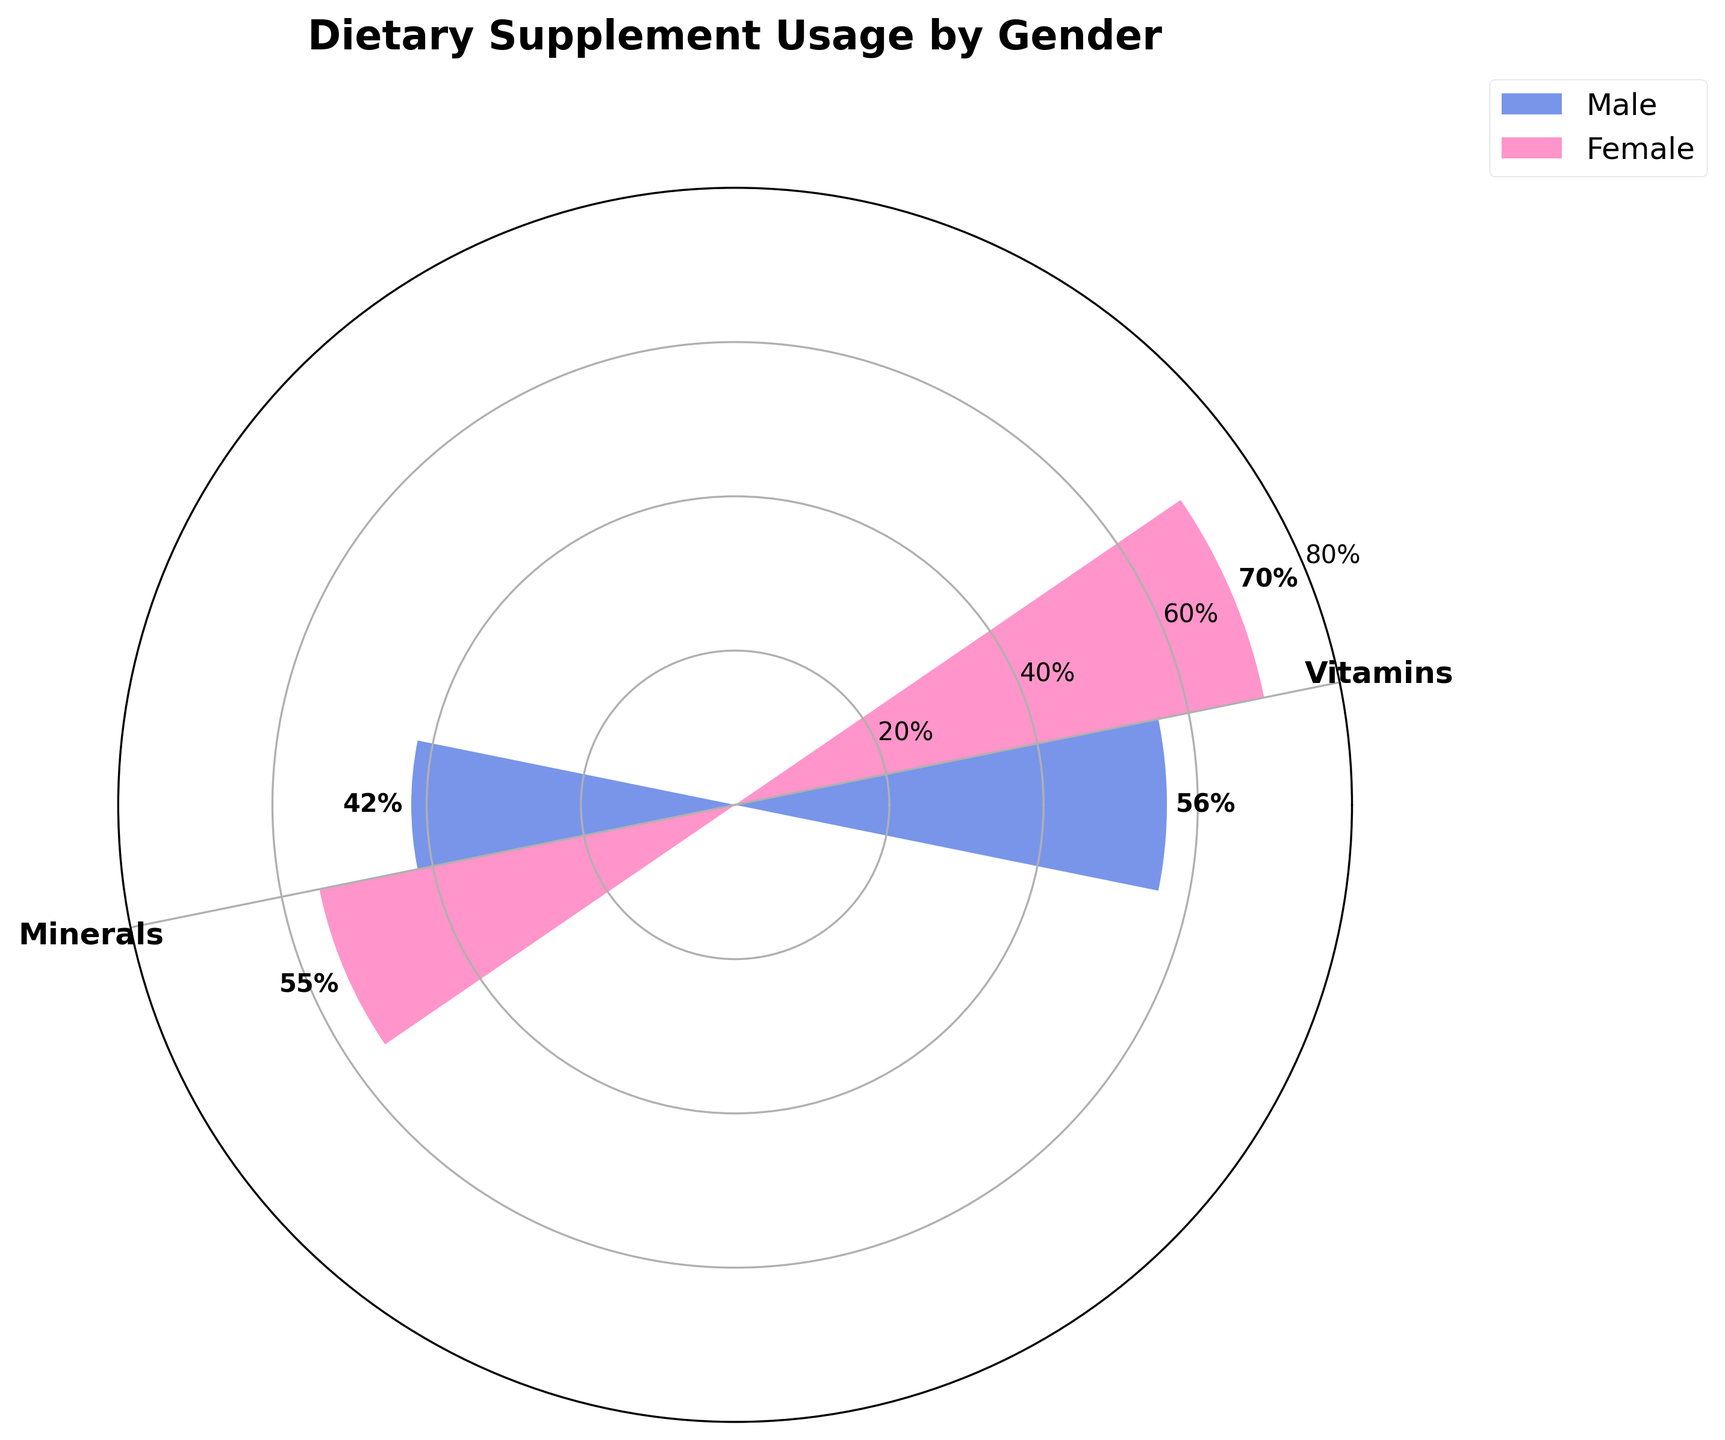What is the title of the chart? The title of the chart is located at the top and reads "Dietary Supplement Usage by Gender".
Answer: Dietary Supplement Usage by Gender How many groups are shown in the chart and what are their names? The chart shows two groups, labeled as "Vitamins" and "Minerals" in the legend.
Answer: 2, Vitamins and Minerals Which gender has the highest usage rate of vitamins? By looking at the bars for Vitamins, the Female bar is taller compared to the Male bar, indicating that females have the highest usage rate of vitamins.
Answer: Female What is the difference in usage rate of minerals between males and females? The usage rate of minerals for males is 42% and for females is 55%. The difference is calculated as 55% - 42%.
Answer: 13% What colors represent male and female in the chart? Males are represented by blue bars, and females are represented by pink bars as indicated in the legend.
Answer: Blue (Male) and Pink (Female) What is the average usage rate of vitamins for all genders? The usage rates for vitamins are 56% for males and 70% for females. To find the average, add both values and divide by 2: (56 + 70) / 2.
Answer: 63% Which group shows a greater difference in usage rates between genders, vitamins or minerals? The difference for vitamins is 70% - 56% = 14%, and for minerals, it is 55% - 42% = 13%. Since 14% is greater than 13%, vitamins show a greater difference.
Answer: Vitamins By how many percentage points do females lead males in overall dietary supplement usage if considering both groups? For vitamins, the difference is 70% - 56% = 14%. For minerals, it is 55% - 42% = 13%. Summing these differences gives 14% + 13%. Noting both genders using one comparison, the total difference is 27%.
Answer: 27% What is the total usage rate of minerals across both genders? Adding the usage rates for minerals for both genders: 42% (Males) + 55% (Females).
Answer: 97% Are the angles used to separate the groups different in the chart? The angles between the groups (Vitamins and Minerals) are evenly spaced, as indicated by their equal size segments in the polar chart.
Answer: No 